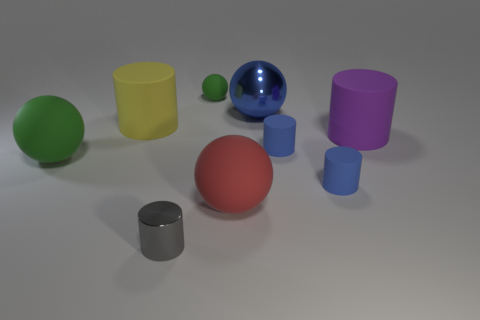There is a big object that is the same color as the tiny matte sphere; what is its shape? The big object sharing the color with the tiny matte sphere is spherical in shape, showcasing a uniform curvature and smooth surface characteristic of spheres. 